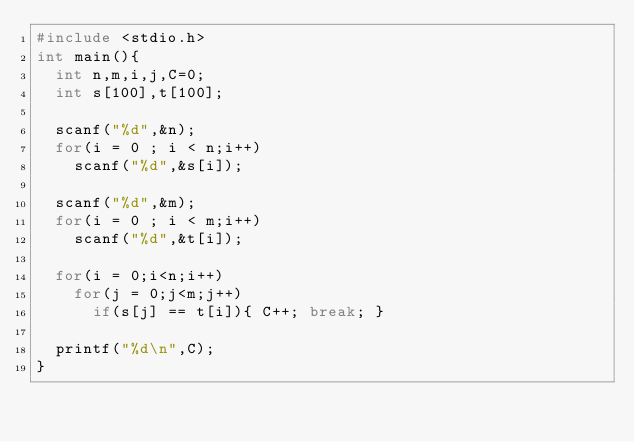<code> <loc_0><loc_0><loc_500><loc_500><_C_>#include <stdio.h>
int main(){
  int n,m,i,j,C=0;
  int s[100],t[100];

  scanf("%d",&n);
  for(i = 0 ; i < n;i++)
    scanf("%d",&s[i]);

  scanf("%d",&m);
  for(i = 0 ; i < m;i++)
    scanf("%d",&t[i]);

  for(i = 0;i<n;i++)
    for(j = 0;j<m;j++)
      if(s[j] == t[i]){ C++; break; }

  printf("%d\n",C);
}</code> 